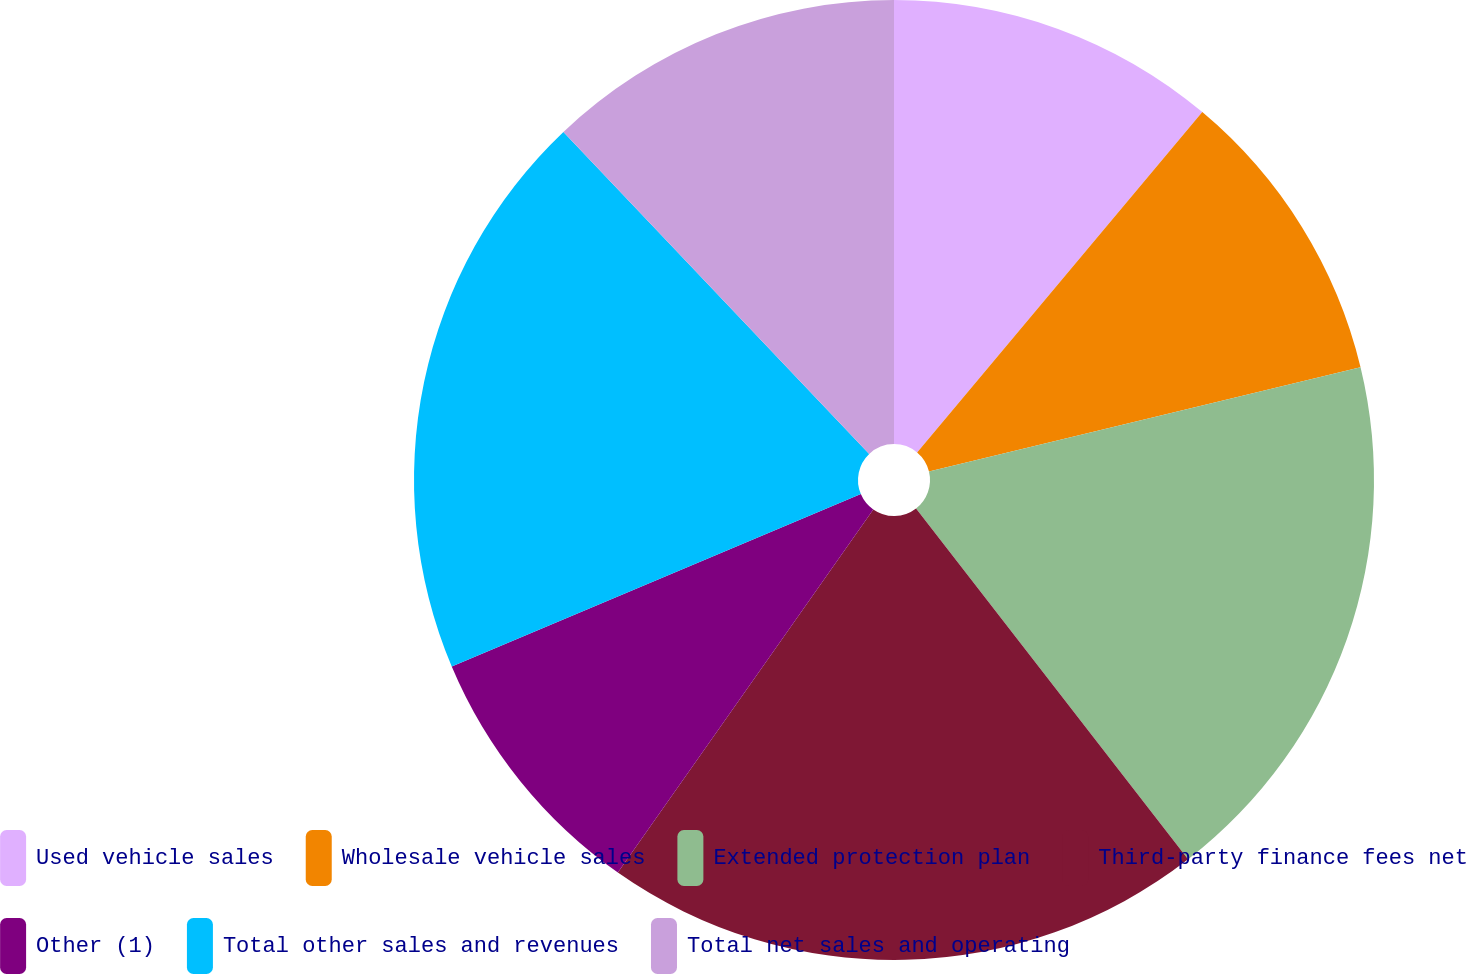Convert chart. <chart><loc_0><loc_0><loc_500><loc_500><pie_chart><fcel>Used vehicle sales<fcel>Wholesale vehicle sales<fcel>Extended protection plan<fcel>Third-party finance fees net<fcel>Other (1)<fcel>Total other sales and revenues<fcel>Total net sales and operating<nl><fcel>11.1%<fcel>10.12%<fcel>18.28%<fcel>20.25%<fcel>8.89%<fcel>19.26%<fcel>12.09%<nl></chart> 